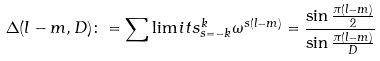Convert formula to latex. <formula><loc_0><loc_0><loc_500><loc_500>\Delta ( l - m , D ) \colon = \sum \lim i t s _ { s = - k } ^ { k } \omega ^ { s ( l - m ) } = \frac { \sin \frac { \pi ( l - m ) } { 2 } } { \sin \frac { \pi ( l - m ) } { D } }</formula> 